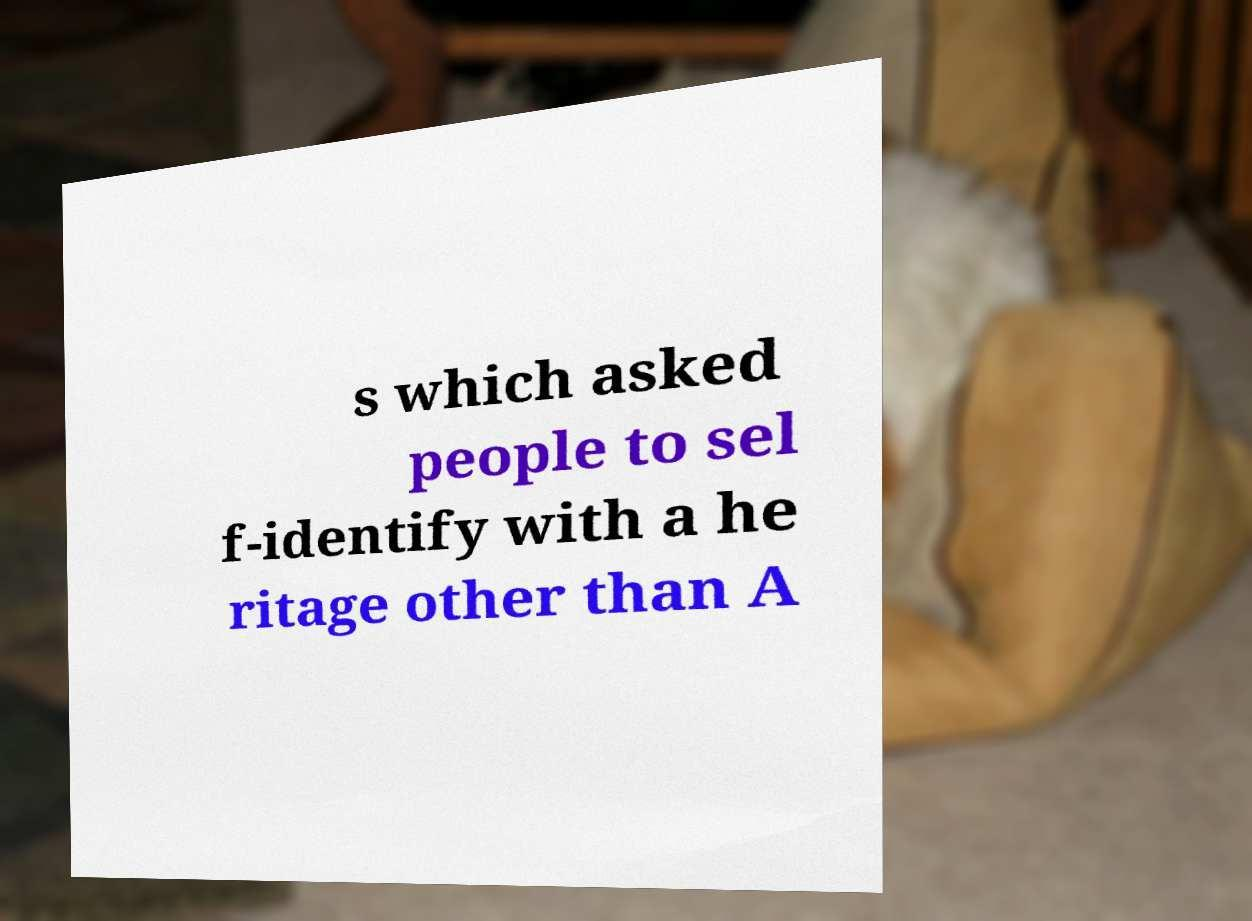I need the written content from this picture converted into text. Can you do that? s which asked people to sel f-identify with a he ritage other than A 